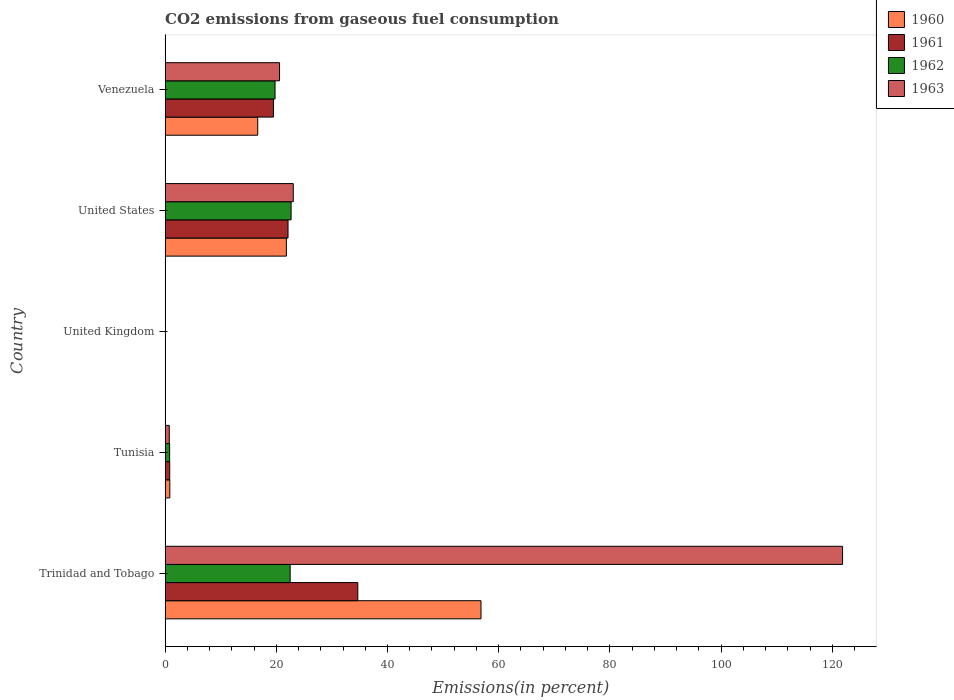How many different coloured bars are there?
Your response must be concise. 4. Are the number of bars per tick equal to the number of legend labels?
Ensure brevity in your answer.  Yes. Are the number of bars on each tick of the Y-axis equal?
Offer a terse response. Yes. How many bars are there on the 2nd tick from the top?
Make the answer very short. 4. How many bars are there on the 2nd tick from the bottom?
Offer a terse response. 4. What is the total CO2 emitted in 1960 in Venezuela?
Provide a succinct answer. 16.66. Across all countries, what is the maximum total CO2 emitted in 1963?
Your answer should be very brief. 121.85. Across all countries, what is the minimum total CO2 emitted in 1961?
Provide a short and direct response. 0.03. In which country was the total CO2 emitted in 1963 maximum?
Your answer should be compact. Trinidad and Tobago. In which country was the total CO2 emitted in 1960 minimum?
Make the answer very short. United Kingdom. What is the total total CO2 emitted in 1960 in the graph?
Provide a succinct answer. 96.17. What is the difference between the total CO2 emitted in 1963 in Tunisia and that in Venezuela?
Provide a succinct answer. -19.83. What is the difference between the total CO2 emitted in 1962 in Tunisia and the total CO2 emitted in 1963 in Venezuela?
Make the answer very short. -19.77. What is the average total CO2 emitted in 1963 per country?
Provide a succinct answer. 33.26. What is the difference between the total CO2 emitted in 1960 and total CO2 emitted in 1961 in United States?
Give a very brief answer. -0.3. In how many countries, is the total CO2 emitted in 1961 greater than 48 %?
Keep it short and to the point. 0. What is the ratio of the total CO2 emitted in 1962 in Trinidad and Tobago to that in United States?
Keep it short and to the point. 0.99. Is the total CO2 emitted in 1963 in Tunisia less than that in United States?
Give a very brief answer. Yes. What is the difference between the highest and the second highest total CO2 emitted in 1961?
Your answer should be compact. 12.55. What is the difference between the highest and the lowest total CO2 emitted in 1961?
Provide a succinct answer. 34.64. Is the sum of the total CO2 emitted in 1960 in Tunisia and United States greater than the maximum total CO2 emitted in 1963 across all countries?
Give a very brief answer. No. Is it the case that in every country, the sum of the total CO2 emitted in 1960 and total CO2 emitted in 1961 is greater than the sum of total CO2 emitted in 1962 and total CO2 emitted in 1963?
Offer a terse response. No. How many bars are there?
Your answer should be very brief. 20. Are all the bars in the graph horizontal?
Keep it short and to the point. Yes. How many countries are there in the graph?
Make the answer very short. 5. Does the graph contain any zero values?
Offer a terse response. No. Where does the legend appear in the graph?
Your answer should be very brief. Top right. What is the title of the graph?
Make the answer very short. CO2 emissions from gaseous fuel consumption. Does "1963" appear as one of the legend labels in the graph?
Your answer should be very brief. Yes. What is the label or title of the X-axis?
Ensure brevity in your answer.  Emissions(in percent). What is the label or title of the Y-axis?
Keep it short and to the point. Country. What is the Emissions(in percent) of 1960 in Trinidad and Tobago?
Your answer should be compact. 56.82. What is the Emissions(in percent) of 1961 in Trinidad and Tobago?
Offer a very short reply. 34.66. What is the Emissions(in percent) in 1962 in Trinidad and Tobago?
Give a very brief answer. 22.49. What is the Emissions(in percent) in 1963 in Trinidad and Tobago?
Make the answer very short. 121.85. What is the Emissions(in percent) in 1960 in Tunisia?
Your answer should be compact. 0.85. What is the Emissions(in percent) in 1961 in Tunisia?
Provide a succinct answer. 0.83. What is the Emissions(in percent) in 1962 in Tunisia?
Ensure brevity in your answer.  0.82. What is the Emissions(in percent) of 1963 in Tunisia?
Keep it short and to the point. 0.75. What is the Emissions(in percent) of 1960 in United Kingdom?
Give a very brief answer. 0.03. What is the Emissions(in percent) of 1961 in United Kingdom?
Keep it short and to the point. 0.03. What is the Emissions(in percent) of 1962 in United Kingdom?
Your answer should be compact. 0.04. What is the Emissions(in percent) in 1963 in United Kingdom?
Your response must be concise. 0.05. What is the Emissions(in percent) of 1960 in United States?
Your answer should be compact. 21.81. What is the Emissions(in percent) of 1961 in United States?
Keep it short and to the point. 22.11. What is the Emissions(in percent) of 1962 in United States?
Offer a very short reply. 22.66. What is the Emissions(in percent) of 1963 in United States?
Your answer should be very brief. 23.05. What is the Emissions(in percent) of 1960 in Venezuela?
Provide a short and direct response. 16.66. What is the Emissions(in percent) of 1961 in Venezuela?
Your answer should be compact. 19.49. What is the Emissions(in percent) in 1962 in Venezuela?
Offer a terse response. 19.78. What is the Emissions(in percent) in 1963 in Venezuela?
Ensure brevity in your answer.  20.58. Across all countries, what is the maximum Emissions(in percent) of 1960?
Keep it short and to the point. 56.82. Across all countries, what is the maximum Emissions(in percent) in 1961?
Your answer should be very brief. 34.66. Across all countries, what is the maximum Emissions(in percent) in 1962?
Offer a terse response. 22.66. Across all countries, what is the maximum Emissions(in percent) of 1963?
Provide a short and direct response. 121.85. Across all countries, what is the minimum Emissions(in percent) of 1960?
Make the answer very short. 0.03. Across all countries, what is the minimum Emissions(in percent) in 1961?
Your response must be concise. 0.03. Across all countries, what is the minimum Emissions(in percent) in 1962?
Offer a terse response. 0.04. Across all countries, what is the minimum Emissions(in percent) in 1963?
Offer a very short reply. 0.05. What is the total Emissions(in percent) in 1960 in the graph?
Make the answer very short. 96.17. What is the total Emissions(in percent) of 1961 in the graph?
Provide a short and direct response. 77.12. What is the total Emissions(in percent) in 1962 in the graph?
Your answer should be compact. 65.78. What is the total Emissions(in percent) in 1963 in the graph?
Give a very brief answer. 166.29. What is the difference between the Emissions(in percent) in 1960 in Trinidad and Tobago and that in Tunisia?
Keep it short and to the point. 55.97. What is the difference between the Emissions(in percent) of 1961 in Trinidad and Tobago and that in Tunisia?
Make the answer very short. 33.83. What is the difference between the Emissions(in percent) of 1962 in Trinidad and Tobago and that in Tunisia?
Offer a very short reply. 21.68. What is the difference between the Emissions(in percent) in 1963 in Trinidad and Tobago and that in Tunisia?
Your answer should be compact. 121.1. What is the difference between the Emissions(in percent) of 1960 in Trinidad and Tobago and that in United Kingdom?
Your answer should be very brief. 56.79. What is the difference between the Emissions(in percent) of 1961 in Trinidad and Tobago and that in United Kingdom?
Offer a very short reply. 34.64. What is the difference between the Emissions(in percent) of 1962 in Trinidad and Tobago and that in United Kingdom?
Provide a succinct answer. 22.46. What is the difference between the Emissions(in percent) of 1963 in Trinidad and Tobago and that in United Kingdom?
Ensure brevity in your answer.  121.8. What is the difference between the Emissions(in percent) of 1960 in Trinidad and Tobago and that in United States?
Offer a very short reply. 35.01. What is the difference between the Emissions(in percent) in 1961 in Trinidad and Tobago and that in United States?
Make the answer very short. 12.55. What is the difference between the Emissions(in percent) in 1962 in Trinidad and Tobago and that in United States?
Offer a terse response. -0.17. What is the difference between the Emissions(in percent) of 1963 in Trinidad and Tobago and that in United States?
Your answer should be compact. 98.8. What is the difference between the Emissions(in percent) of 1960 in Trinidad and Tobago and that in Venezuela?
Provide a succinct answer. 40.16. What is the difference between the Emissions(in percent) in 1961 in Trinidad and Tobago and that in Venezuela?
Keep it short and to the point. 15.17. What is the difference between the Emissions(in percent) in 1962 in Trinidad and Tobago and that in Venezuela?
Offer a terse response. 2.72. What is the difference between the Emissions(in percent) of 1963 in Trinidad and Tobago and that in Venezuela?
Your answer should be very brief. 101.26. What is the difference between the Emissions(in percent) in 1960 in Tunisia and that in United Kingdom?
Offer a very short reply. 0.82. What is the difference between the Emissions(in percent) of 1961 in Tunisia and that in United Kingdom?
Provide a succinct answer. 0.8. What is the difference between the Emissions(in percent) of 1962 in Tunisia and that in United Kingdom?
Provide a short and direct response. 0.78. What is the difference between the Emissions(in percent) in 1963 in Tunisia and that in United Kingdom?
Ensure brevity in your answer.  0.71. What is the difference between the Emissions(in percent) of 1960 in Tunisia and that in United States?
Your response must be concise. -20.96. What is the difference between the Emissions(in percent) in 1961 in Tunisia and that in United States?
Give a very brief answer. -21.28. What is the difference between the Emissions(in percent) of 1962 in Tunisia and that in United States?
Offer a terse response. -21.84. What is the difference between the Emissions(in percent) in 1963 in Tunisia and that in United States?
Your answer should be compact. -22.3. What is the difference between the Emissions(in percent) in 1960 in Tunisia and that in Venezuela?
Ensure brevity in your answer.  -15.81. What is the difference between the Emissions(in percent) in 1961 in Tunisia and that in Venezuela?
Provide a short and direct response. -18.66. What is the difference between the Emissions(in percent) of 1962 in Tunisia and that in Venezuela?
Give a very brief answer. -18.96. What is the difference between the Emissions(in percent) of 1963 in Tunisia and that in Venezuela?
Your response must be concise. -19.83. What is the difference between the Emissions(in percent) in 1960 in United Kingdom and that in United States?
Provide a succinct answer. -21.79. What is the difference between the Emissions(in percent) in 1961 in United Kingdom and that in United States?
Keep it short and to the point. -22.09. What is the difference between the Emissions(in percent) in 1962 in United Kingdom and that in United States?
Provide a succinct answer. -22.62. What is the difference between the Emissions(in percent) of 1963 in United Kingdom and that in United States?
Your response must be concise. -23. What is the difference between the Emissions(in percent) in 1960 in United Kingdom and that in Venezuela?
Keep it short and to the point. -16.64. What is the difference between the Emissions(in percent) in 1961 in United Kingdom and that in Venezuela?
Keep it short and to the point. -19.46. What is the difference between the Emissions(in percent) in 1962 in United Kingdom and that in Venezuela?
Offer a terse response. -19.74. What is the difference between the Emissions(in percent) of 1963 in United Kingdom and that in Venezuela?
Ensure brevity in your answer.  -20.54. What is the difference between the Emissions(in percent) of 1960 in United States and that in Venezuela?
Keep it short and to the point. 5.15. What is the difference between the Emissions(in percent) of 1961 in United States and that in Venezuela?
Provide a succinct answer. 2.62. What is the difference between the Emissions(in percent) of 1962 in United States and that in Venezuela?
Keep it short and to the point. 2.88. What is the difference between the Emissions(in percent) in 1963 in United States and that in Venezuela?
Make the answer very short. 2.47. What is the difference between the Emissions(in percent) in 1960 in Trinidad and Tobago and the Emissions(in percent) in 1961 in Tunisia?
Make the answer very short. 55.99. What is the difference between the Emissions(in percent) of 1960 in Trinidad and Tobago and the Emissions(in percent) of 1962 in Tunisia?
Your answer should be compact. 56. What is the difference between the Emissions(in percent) in 1960 in Trinidad and Tobago and the Emissions(in percent) in 1963 in Tunisia?
Your answer should be very brief. 56.06. What is the difference between the Emissions(in percent) in 1961 in Trinidad and Tobago and the Emissions(in percent) in 1962 in Tunisia?
Provide a short and direct response. 33.84. What is the difference between the Emissions(in percent) in 1961 in Trinidad and Tobago and the Emissions(in percent) in 1963 in Tunisia?
Ensure brevity in your answer.  33.91. What is the difference between the Emissions(in percent) in 1962 in Trinidad and Tobago and the Emissions(in percent) in 1963 in Tunisia?
Give a very brief answer. 21.74. What is the difference between the Emissions(in percent) in 1960 in Trinidad and Tobago and the Emissions(in percent) in 1961 in United Kingdom?
Your answer should be very brief. 56.79. What is the difference between the Emissions(in percent) of 1960 in Trinidad and Tobago and the Emissions(in percent) of 1962 in United Kingdom?
Offer a terse response. 56.78. What is the difference between the Emissions(in percent) in 1960 in Trinidad and Tobago and the Emissions(in percent) in 1963 in United Kingdom?
Provide a succinct answer. 56.77. What is the difference between the Emissions(in percent) in 1961 in Trinidad and Tobago and the Emissions(in percent) in 1962 in United Kingdom?
Give a very brief answer. 34.62. What is the difference between the Emissions(in percent) of 1961 in Trinidad and Tobago and the Emissions(in percent) of 1963 in United Kingdom?
Provide a succinct answer. 34.61. What is the difference between the Emissions(in percent) of 1962 in Trinidad and Tobago and the Emissions(in percent) of 1963 in United Kingdom?
Provide a succinct answer. 22.44. What is the difference between the Emissions(in percent) in 1960 in Trinidad and Tobago and the Emissions(in percent) in 1961 in United States?
Make the answer very short. 34.71. What is the difference between the Emissions(in percent) of 1960 in Trinidad and Tobago and the Emissions(in percent) of 1962 in United States?
Your response must be concise. 34.16. What is the difference between the Emissions(in percent) of 1960 in Trinidad and Tobago and the Emissions(in percent) of 1963 in United States?
Offer a very short reply. 33.77. What is the difference between the Emissions(in percent) in 1961 in Trinidad and Tobago and the Emissions(in percent) in 1962 in United States?
Your answer should be very brief. 12. What is the difference between the Emissions(in percent) in 1961 in Trinidad and Tobago and the Emissions(in percent) in 1963 in United States?
Ensure brevity in your answer.  11.61. What is the difference between the Emissions(in percent) of 1962 in Trinidad and Tobago and the Emissions(in percent) of 1963 in United States?
Give a very brief answer. -0.56. What is the difference between the Emissions(in percent) in 1960 in Trinidad and Tobago and the Emissions(in percent) in 1961 in Venezuela?
Offer a terse response. 37.33. What is the difference between the Emissions(in percent) of 1960 in Trinidad and Tobago and the Emissions(in percent) of 1962 in Venezuela?
Offer a very short reply. 37.04. What is the difference between the Emissions(in percent) in 1960 in Trinidad and Tobago and the Emissions(in percent) in 1963 in Venezuela?
Your answer should be very brief. 36.23. What is the difference between the Emissions(in percent) in 1961 in Trinidad and Tobago and the Emissions(in percent) in 1962 in Venezuela?
Offer a very short reply. 14.88. What is the difference between the Emissions(in percent) of 1961 in Trinidad and Tobago and the Emissions(in percent) of 1963 in Venezuela?
Keep it short and to the point. 14.08. What is the difference between the Emissions(in percent) in 1962 in Trinidad and Tobago and the Emissions(in percent) in 1963 in Venezuela?
Offer a terse response. 1.91. What is the difference between the Emissions(in percent) in 1960 in Tunisia and the Emissions(in percent) in 1961 in United Kingdom?
Your response must be concise. 0.82. What is the difference between the Emissions(in percent) in 1960 in Tunisia and the Emissions(in percent) in 1962 in United Kingdom?
Your answer should be very brief. 0.81. What is the difference between the Emissions(in percent) in 1960 in Tunisia and the Emissions(in percent) in 1963 in United Kingdom?
Make the answer very short. 0.8. What is the difference between the Emissions(in percent) in 1961 in Tunisia and the Emissions(in percent) in 1962 in United Kingdom?
Your answer should be very brief. 0.79. What is the difference between the Emissions(in percent) of 1961 in Tunisia and the Emissions(in percent) of 1963 in United Kingdom?
Provide a short and direct response. 0.78. What is the difference between the Emissions(in percent) of 1962 in Tunisia and the Emissions(in percent) of 1963 in United Kingdom?
Offer a terse response. 0.77. What is the difference between the Emissions(in percent) in 1960 in Tunisia and the Emissions(in percent) in 1961 in United States?
Ensure brevity in your answer.  -21.26. What is the difference between the Emissions(in percent) of 1960 in Tunisia and the Emissions(in percent) of 1962 in United States?
Keep it short and to the point. -21.81. What is the difference between the Emissions(in percent) of 1960 in Tunisia and the Emissions(in percent) of 1963 in United States?
Offer a terse response. -22.2. What is the difference between the Emissions(in percent) of 1961 in Tunisia and the Emissions(in percent) of 1962 in United States?
Offer a terse response. -21.83. What is the difference between the Emissions(in percent) in 1961 in Tunisia and the Emissions(in percent) in 1963 in United States?
Provide a short and direct response. -22.22. What is the difference between the Emissions(in percent) in 1962 in Tunisia and the Emissions(in percent) in 1963 in United States?
Provide a succinct answer. -22.24. What is the difference between the Emissions(in percent) in 1960 in Tunisia and the Emissions(in percent) in 1961 in Venezuela?
Give a very brief answer. -18.64. What is the difference between the Emissions(in percent) in 1960 in Tunisia and the Emissions(in percent) in 1962 in Venezuela?
Give a very brief answer. -18.93. What is the difference between the Emissions(in percent) of 1960 in Tunisia and the Emissions(in percent) of 1963 in Venezuela?
Your answer should be compact. -19.74. What is the difference between the Emissions(in percent) in 1961 in Tunisia and the Emissions(in percent) in 1962 in Venezuela?
Offer a very short reply. -18.95. What is the difference between the Emissions(in percent) of 1961 in Tunisia and the Emissions(in percent) of 1963 in Venezuela?
Provide a succinct answer. -19.75. What is the difference between the Emissions(in percent) in 1962 in Tunisia and the Emissions(in percent) in 1963 in Venezuela?
Ensure brevity in your answer.  -19.77. What is the difference between the Emissions(in percent) of 1960 in United Kingdom and the Emissions(in percent) of 1961 in United States?
Provide a short and direct response. -22.09. What is the difference between the Emissions(in percent) in 1960 in United Kingdom and the Emissions(in percent) in 1962 in United States?
Provide a short and direct response. -22.63. What is the difference between the Emissions(in percent) of 1960 in United Kingdom and the Emissions(in percent) of 1963 in United States?
Offer a terse response. -23.03. What is the difference between the Emissions(in percent) of 1961 in United Kingdom and the Emissions(in percent) of 1962 in United States?
Give a very brief answer. -22.64. What is the difference between the Emissions(in percent) of 1961 in United Kingdom and the Emissions(in percent) of 1963 in United States?
Make the answer very short. -23.03. What is the difference between the Emissions(in percent) of 1962 in United Kingdom and the Emissions(in percent) of 1963 in United States?
Make the answer very short. -23.02. What is the difference between the Emissions(in percent) in 1960 in United Kingdom and the Emissions(in percent) in 1961 in Venezuela?
Provide a succinct answer. -19.46. What is the difference between the Emissions(in percent) in 1960 in United Kingdom and the Emissions(in percent) in 1962 in Venezuela?
Make the answer very short. -19.75. What is the difference between the Emissions(in percent) in 1960 in United Kingdom and the Emissions(in percent) in 1963 in Venezuela?
Ensure brevity in your answer.  -20.56. What is the difference between the Emissions(in percent) of 1961 in United Kingdom and the Emissions(in percent) of 1962 in Venezuela?
Give a very brief answer. -19.75. What is the difference between the Emissions(in percent) of 1961 in United Kingdom and the Emissions(in percent) of 1963 in Venezuela?
Keep it short and to the point. -20.56. What is the difference between the Emissions(in percent) in 1962 in United Kingdom and the Emissions(in percent) in 1963 in Venezuela?
Your answer should be compact. -20.55. What is the difference between the Emissions(in percent) of 1960 in United States and the Emissions(in percent) of 1961 in Venezuela?
Offer a very short reply. 2.32. What is the difference between the Emissions(in percent) in 1960 in United States and the Emissions(in percent) in 1962 in Venezuela?
Your response must be concise. 2.04. What is the difference between the Emissions(in percent) in 1960 in United States and the Emissions(in percent) in 1963 in Venezuela?
Your response must be concise. 1.23. What is the difference between the Emissions(in percent) in 1961 in United States and the Emissions(in percent) in 1962 in Venezuela?
Provide a short and direct response. 2.34. What is the difference between the Emissions(in percent) of 1961 in United States and the Emissions(in percent) of 1963 in Venezuela?
Your answer should be very brief. 1.53. What is the difference between the Emissions(in percent) of 1962 in United States and the Emissions(in percent) of 1963 in Venezuela?
Offer a very short reply. 2.08. What is the average Emissions(in percent) in 1960 per country?
Your answer should be compact. 19.23. What is the average Emissions(in percent) of 1961 per country?
Provide a succinct answer. 15.42. What is the average Emissions(in percent) in 1962 per country?
Your response must be concise. 13.16. What is the average Emissions(in percent) of 1963 per country?
Ensure brevity in your answer.  33.26. What is the difference between the Emissions(in percent) of 1960 and Emissions(in percent) of 1961 in Trinidad and Tobago?
Give a very brief answer. 22.16. What is the difference between the Emissions(in percent) in 1960 and Emissions(in percent) in 1962 in Trinidad and Tobago?
Your response must be concise. 34.33. What is the difference between the Emissions(in percent) in 1960 and Emissions(in percent) in 1963 in Trinidad and Tobago?
Offer a terse response. -65.03. What is the difference between the Emissions(in percent) in 1961 and Emissions(in percent) in 1962 in Trinidad and Tobago?
Make the answer very short. 12.17. What is the difference between the Emissions(in percent) of 1961 and Emissions(in percent) of 1963 in Trinidad and Tobago?
Keep it short and to the point. -87.19. What is the difference between the Emissions(in percent) in 1962 and Emissions(in percent) in 1963 in Trinidad and Tobago?
Your response must be concise. -99.36. What is the difference between the Emissions(in percent) in 1960 and Emissions(in percent) in 1961 in Tunisia?
Ensure brevity in your answer.  0.02. What is the difference between the Emissions(in percent) in 1960 and Emissions(in percent) in 1962 in Tunisia?
Keep it short and to the point. 0.03. What is the difference between the Emissions(in percent) in 1960 and Emissions(in percent) in 1963 in Tunisia?
Offer a very short reply. 0.1. What is the difference between the Emissions(in percent) of 1961 and Emissions(in percent) of 1962 in Tunisia?
Offer a very short reply. 0.01. What is the difference between the Emissions(in percent) in 1961 and Emissions(in percent) in 1963 in Tunisia?
Offer a very short reply. 0.08. What is the difference between the Emissions(in percent) in 1962 and Emissions(in percent) in 1963 in Tunisia?
Your answer should be compact. 0.06. What is the difference between the Emissions(in percent) in 1960 and Emissions(in percent) in 1961 in United Kingdom?
Make the answer very short. 0. What is the difference between the Emissions(in percent) in 1960 and Emissions(in percent) in 1962 in United Kingdom?
Your response must be concise. -0.01. What is the difference between the Emissions(in percent) in 1960 and Emissions(in percent) in 1963 in United Kingdom?
Provide a succinct answer. -0.02. What is the difference between the Emissions(in percent) of 1961 and Emissions(in percent) of 1962 in United Kingdom?
Your response must be concise. -0.01. What is the difference between the Emissions(in percent) in 1961 and Emissions(in percent) in 1963 in United Kingdom?
Provide a short and direct response. -0.02. What is the difference between the Emissions(in percent) of 1962 and Emissions(in percent) of 1963 in United Kingdom?
Offer a very short reply. -0.01. What is the difference between the Emissions(in percent) in 1960 and Emissions(in percent) in 1961 in United States?
Offer a terse response. -0.3. What is the difference between the Emissions(in percent) of 1960 and Emissions(in percent) of 1962 in United States?
Your answer should be very brief. -0.85. What is the difference between the Emissions(in percent) of 1960 and Emissions(in percent) of 1963 in United States?
Offer a very short reply. -1.24. What is the difference between the Emissions(in percent) in 1961 and Emissions(in percent) in 1962 in United States?
Ensure brevity in your answer.  -0.55. What is the difference between the Emissions(in percent) of 1961 and Emissions(in percent) of 1963 in United States?
Provide a short and direct response. -0.94. What is the difference between the Emissions(in percent) of 1962 and Emissions(in percent) of 1963 in United States?
Ensure brevity in your answer.  -0.39. What is the difference between the Emissions(in percent) in 1960 and Emissions(in percent) in 1961 in Venezuela?
Provide a short and direct response. -2.83. What is the difference between the Emissions(in percent) in 1960 and Emissions(in percent) in 1962 in Venezuela?
Give a very brief answer. -3.12. What is the difference between the Emissions(in percent) of 1960 and Emissions(in percent) of 1963 in Venezuela?
Provide a short and direct response. -3.92. What is the difference between the Emissions(in percent) in 1961 and Emissions(in percent) in 1962 in Venezuela?
Make the answer very short. -0.29. What is the difference between the Emissions(in percent) in 1961 and Emissions(in percent) in 1963 in Venezuela?
Make the answer very short. -1.09. What is the difference between the Emissions(in percent) in 1962 and Emissions(in percent) in 1963 in Venezuela?
Your answer should be very brief. -0.81. What is the ratio of the Emissions(in percent) in 1960 in Trinidad and Tobago to that in Tunisia?
Your answer should be compact. 66.9. What is the ratio of the Emissions(in percent) of 1961 in Trinidad and Tobago to that in Tunisia?
Keep it short and to the point. 41.77. What is the ratio of the Emissions(in percent) in 1962 in Trinidad and Tobago to that in Tunisia?
Offer a very short reply. 27.55. What is the ratio of the Emissions(in percent) of 1963 in Trinidad and Tobago to that in Tunisia?
Make the answer very short. 161.75. What is the ratio of the Emissions(in percent) of 1960 in Trinidad and Tobago to that in United Kingdom?
Provide a succinct answer. 2208.15. What is the ratio of the Emissions(in percent) of 1961 in Trinidad and Tobago to that in United Kingdom?
Offer a very short reply. 1357.75. What is the ratio of the Emissions(in percent) in 1962 in Trinidad and Tobago to that in United Kingdom?
Ensure brevity in your answer.  616.87. What is the ratio of the Emissions(in percent) of 1963 in Trinidad and Tobago to that in United Kingdom?
Offer a very short reply. 2539.76. What is the ratio of the Emissions(in percent) in 1960 in Trinidad and Tobago to that in United States?
Ensure brevity in your answer.  2.6. What is the ratio of the Emissions(in percent) of 1961 in Trinidad and Tobago to that in United States?
Offer a very short reply. 1.57. What is the ratio of the Emissions(in percent) of 1962 in Trinidad and Tobago to that in United States?
Your response must be concise. 0.99. What is the ratio of the Emissions(in percent) in 1963 in Trinidad and Tobago to that in United States?
Ensure brevity in your answer.  5.29. What is the ratio of the Emissions(in percent) of 1960 in Trinidad and Tobago to that in Venezuela?
Offer a terse response. 3.41. What is the ratio of the Emissions(in percent) in 1961 in Trinidad and Tobago to that in Venezuela?
Your answer should be very brief. 1.78. What is the ratio of the Emissions(in percent) of 1962 in Trinidad and Tobago to that in Venezuela?
Offer a terse response. 1.14. What is the ratio of the Emissions(in percent) in 1963 in Trinidad and Tobago to that in Venezuela?
Your response must be concise. 5.92. What is the ratio of the Emissions(in percent) of 1960 in Tunisia to that in United Kingdom?
Provide a short and direct response. 33.01. What is the ratio of the Emissions(in percent) in 1961 in Tunisia to that in United Kingdom?
Your answer should be compact. 32.51. What is the ratio of the Emissions(in percent) in 1962 in Tunisia to that in United Kingdom?
Ensure brevity in your answer.  22.39. What is the ratio of the Emissions(in percent) of 1963 in Tunisia to that in United Kingdom?
Provide a short and direct response. 15.7. What is the ratio of the Emissions(in percent) in 1960 in Tunisia to that in United States?
Your response must be concise. 0.04. What is the ratio of the Emissions(in percent) of 1961 in Tunisia to that in United States?
Provide a succinct answer. 0.04. What is the ratio of the Emissions(in percent) in 1962 in Tunisia to that in United States?
Provide a short and direct response. 0.04. What is the ratio of the Emissions(in percent) of 1963 in Tunisia to that in United States?
Keep it short and to the point. 0.03. What is the ratio of the Emissions(in percent) of 1960 in Tunisia to that in Venezuela?
Your answer should be very brief. 0.05. What is the ratio of the Emissions(in percent) of 1961 in Tunisia to that in Venezuela?
Provide a succinct answer. 0.04. What is the ratio of the Emissions(in percent) of 1962 in Tunisia to that in Venezuela?
Offer a terse response. 0.04. What is the ratio of the Emissions(in percent) of 1963 in Tunisia to that in Venezuela?
Your answer should be very brief. 0.04. What is the ratio of the Emissions(in percent) in 1960 in United Kingdom to that in United States?
Keep it short and to the point. 0. What is the ratio of the Emissions(in percent) in 1961 in United Kingdom to that in United States?
Your response must be concise. 0. What is the ratio of the Emissions(in percent) of 1962 in United Kingdom to that in United States?
Keep it short and to the point. 0. What is the ratio of the Emissions(in percent) of 1963 in United Kingdom to that in United States?
Your answer should be compact. 0. What is the ratio of the Emissions(in percent) of 1960 in United Kingdom to that in Venezuela?
Ensure brevity in your answer.  0. What is the ratio of the Emissions(in percent) in 1961 in United Kingdom to that in Venezuela?
Make the answer very short. 0. What is the ratio of the Emissions(in percent) of 1962 in United Kingdom to that in Venezuela?
Give a very brief answer. 0. What is the ratio of the Emissions(in percent) of 1963 in United Kingdom to that in Venezuela?
Keep it short and to the point. 0. What is the ratio of the Emissions(in percent) in 1960 in United States to that in Venezuela?
Make the answer very short. 1.31. What is the ratio of the Emissions(in percent) in 1961 in United States to that in Venezuela?
Keep it short and to the point. 1.13. What is the ratio of the Emissions(in percent) of 1962 in United States to that in Venezuela?
Your answer should be compact. 1.15. What is the ratio of the Emissions(in percent) of 1963 in United States to that in Venezuela?
Keep it short and to the point. 1.12. What is the difference between the highest and the second highest Emissions(in percent) in 1960?
Your answer should be compact. 35.01. What is the difference between the highest and the second highest Emissions(in percent) in 1961?
Ensure brevity in your answer.  12.55. What is the difference between the highest and the second highest Emissions(in percent) in 1962?
Provide a short and direct response. 0.17. What is the difference between the highest and the second highest Emissions(in percent) of 1963?
Offer a terse response. 98.8. What is the difference between the highest and the lowest Emissions(in percent) of 1960?
Give a very brief answer. 56.79. What is the difference between the highest and the lowest Emissions(in percent) in 1961?
Provide a short and direct response. 34.64. What is the difference between the highest and the lowest Emissions(in percent) of 1962?
Your answer should be very brief. 22.62. What is the difference between the highest and the lowest Emissions(in percent) of 1963?
Your answer should be very brief. 121.8. 